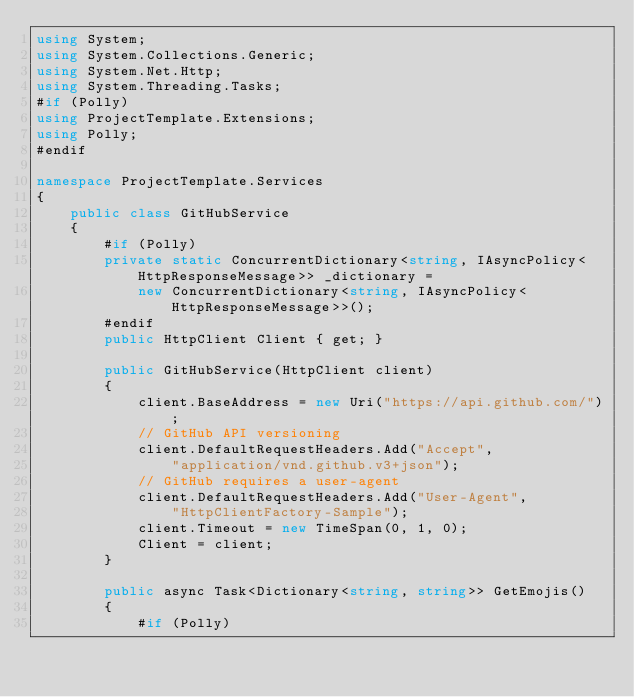<code> <loc_0><loc_0><loc_500><loc_500><_C#_>using System;
using System.Collections.Generic;
using System.Net.Http;
using System.Threading.Tasks;
#if (Polly)
using ProjectTemplate.Extensions;
using Polly;
#endif

namespace ProjectTemplate.Services
{
    public class GitHubService
    {
        #if (Polly)
        private static ConcurrentDictionary<string, IAsyncPolicy<HttpResponseMessage>> _dictionary = 
            new ConcurrentDictionary<string, IAsyncPolicy<HttpResponseMessage>>();
        #endif
        public HttpClient Client { get; }

        public GitHubService(HttpClient client)
        {
            client.BaseAddress = new Uri("https://api.github.com/");
            // GitHub API versioning
            client.DefaultRequestHeaders.Add("Accept", 
                "application/vnd.github.v3+json");
            // GitHub requires a user-agent
            client.DefaultRequestHeaders.Add("User-Agent", 
                "HttpClientFactory-Sample");
            client.Timeout = new TimeSpan(0, 1, 0);
            Client = client;
        }

        public async Task<Dictionary<string, string>> GetEmojis()
        {
            #if (Polly)</code> 